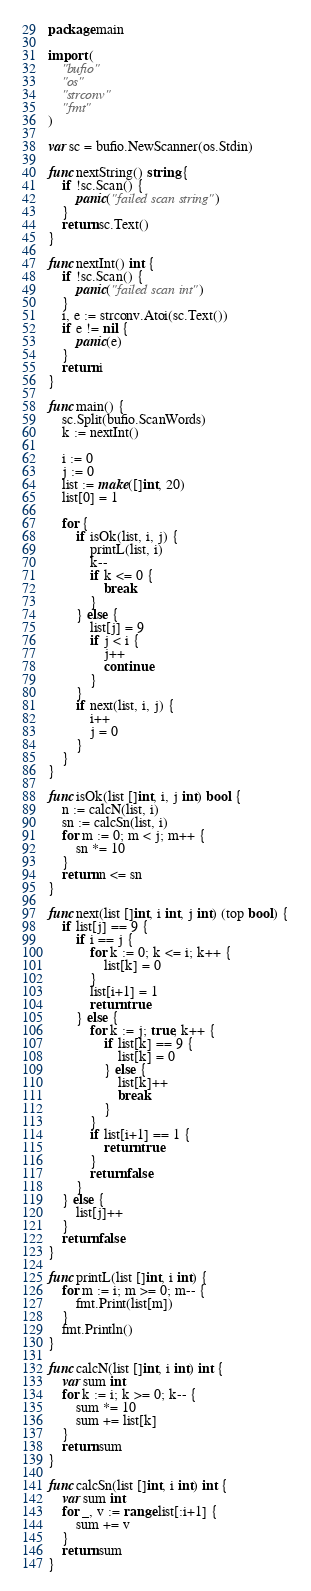<code> <loc_0><loc_0><loc_500><loc_500><_Go_>package main

import (
	"bufio"
	"os"
	"strconv"
	"fmt"
)

var sc = bufio.NewScanner(os.Stdin)

func nextString() string {
	if !sc.Scan() {
		panic("failed scan string")
	}
	return sc.Text()
}

func nextInt() int {
	if !sc.Scan() {
		panic("failed scan int")
	}
	i, e := strconv.Atoi(sc.Text())
	if e != nil {
		panic(e)
	}
	return i
}

func main() {
	sc.Split(bufio.ScanWords)
	k := nextInt()

	i := 0
	j := 0
	list := make([]int, 20)
	list[0] = 1

	for {
		if isOk(list, i, j) {
			printL(list, i)
			k--
			if k <= 0 {
				break
			}
		} else {
			list[j] = 9
			if j < i {
				j++
				continue
			}
		}
		if next(list, i, j) {
			i++
			j = 0
		}
	}
}

func isOk(list []int, i, j int) bool {
	n := calcN(list, i)
	sn := calcSn(list, i)
	for m := 0; m < j; m++ {
		sn *= 10
	}
	return n <= sn
}

func next(list []int, i int, j int) (top bool) {
	if list[j] == 9 {
		if i == j {
			for k := 0; k <= i; k++ {
				list[k] = 0
			}
			list[i+1] = 1
			return true
		} else {
			for k := j; true; k++ {
				if list[k] == 9 {
					list[k] = 0
				} else {
					list[k]++
					break
				}
			}
			if list[i+1] == 1 {
				return true
			}
			return false
		}
	} else {
		list[j]++
	}
	return false
}

func printL(list []int, i int) {
	for m := i; m >= 0; m-- {
		fmt.Print(list[m])
	}
	fmt.Println()
}

func calcN(list []int, i int) int {
	var sum int
	for k := i; k >= 0; k-- {
		sum *= 10
		sum += list[k]
	}
	return sum
}

func calcSn(list []int, i int) int {
	var sum int
	for _, v := range list[:i+1] {
		sum += v
	}
	return sum
}
</code> 